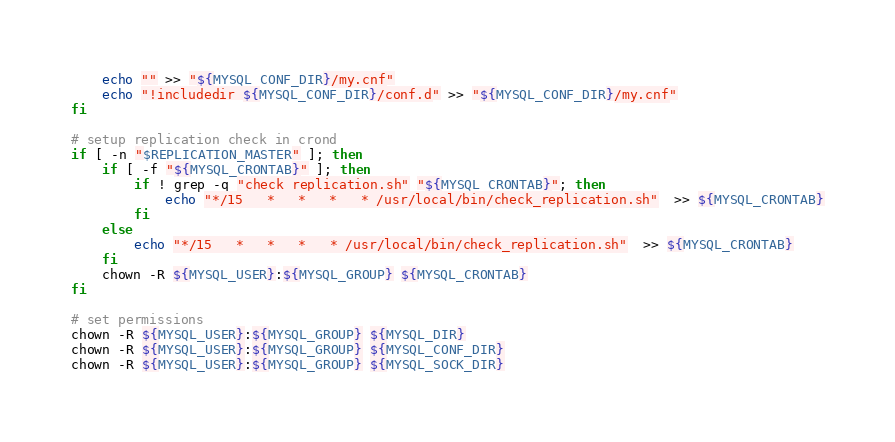<code> <loc_0><loc_0><loc_500><loc_500><_Bash_>	echo "" >> "${MYSQL_CONF_DIR}/my.cnf"
	echo "!includedir ${MYSQL_CONF_DIR}/conf.d" >> "${MYSQL_CONF_DIR}/my.cnf"
fi

# setup replication check in crond
if [ -n "$REPLICATION_MASTER" ]; then
	if [ -f "${MYSQL_CRONTAB}" ]; then
		if ! grep -q "check_replication.sh" "${MYSQL_CRONTAB}"; then
			echo "*/15   *   *   *   * /usr/local/bin/check_replication.sh"  >> ${MYSQL_CRONTAB}
		fi
	else
		echo "*/15   *   *   *   * /usr/local/bin/check_replication.sh"  >> ${MYSQL_CRONTAB}
	fi
	chown -R ${MYSQL_USER}:${MYSQL_GROUP} ${MYSQL_CRONTAB}
fi

# set permissions
chown -R ${MYSQL_USER}:${MYSQL_GROUP} ${MYSQL_DIR}
chown -R ${MYSQL_USER}:${MYSQL_GROUP} ${MYSQL_CONF_DIR}
chown -R ${MYSQL_USER}:${MYSQL_GROUP} ${MYSQL_SOCK_DIR}
</code> 